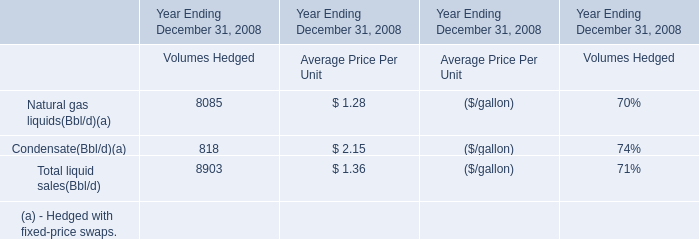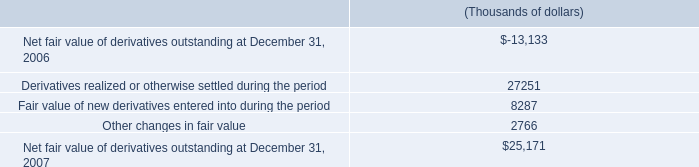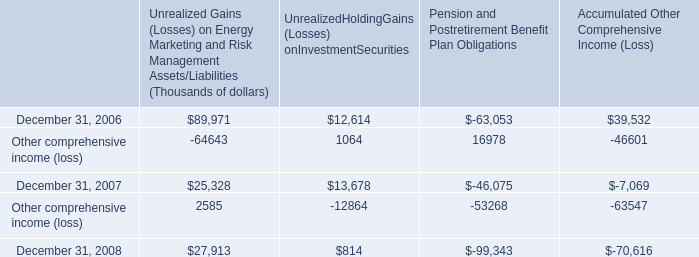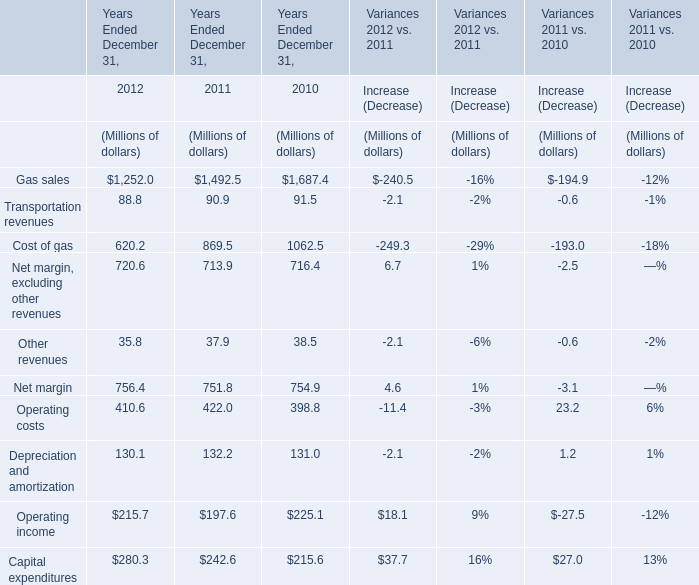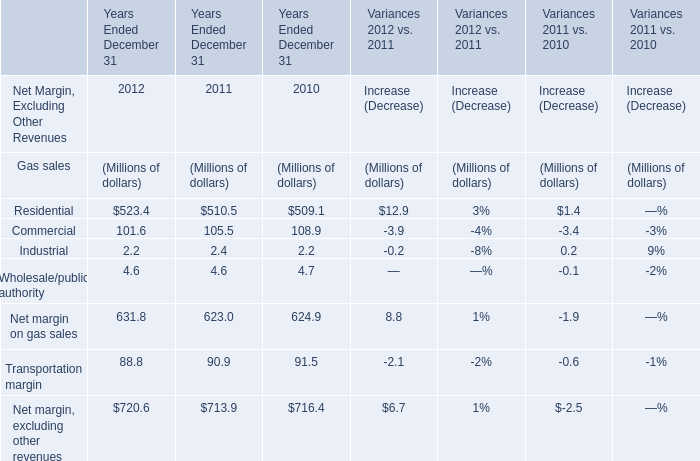Does Net margin keeps increasing each year between 2012 and 2011? 
Answer: Yes. What was the average of Net margin on gas sales in 2010, 2011,2012 ? (in million) 
Computations: (((631.8 + 623) + 624.9) / 3)
Answer: 626.56667. 